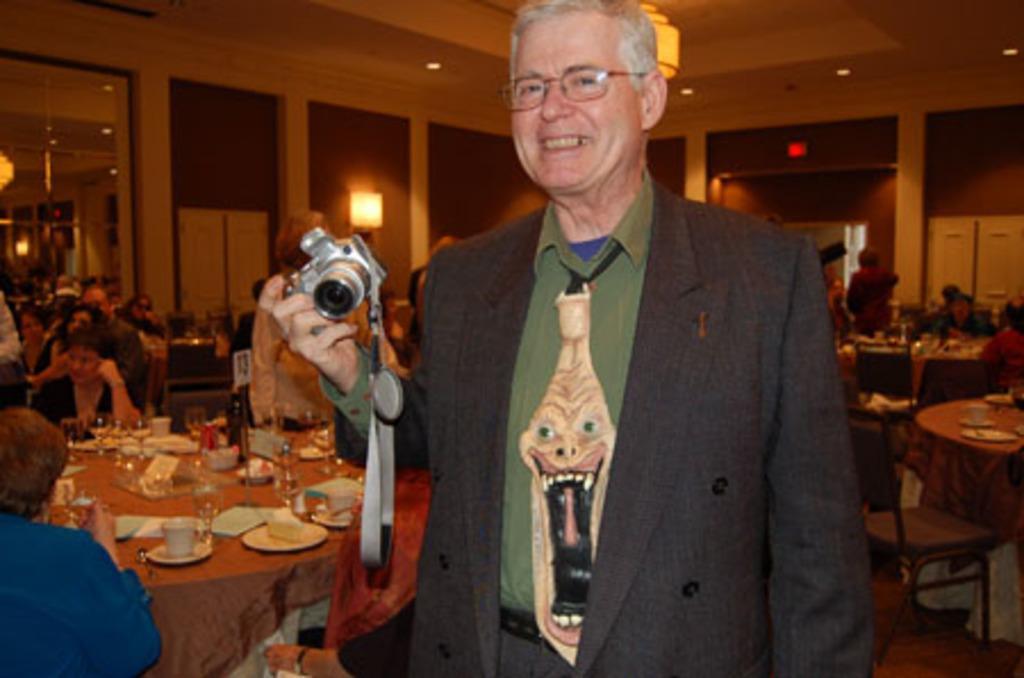Can you describe this image briefly? As we can see in the image there is a wall, mirrors, lamp, few people here and there. The man who is standing in the front is holding camera and there is a table on the left side. On table there are cups, saucers, glasses, plates and tissues. 